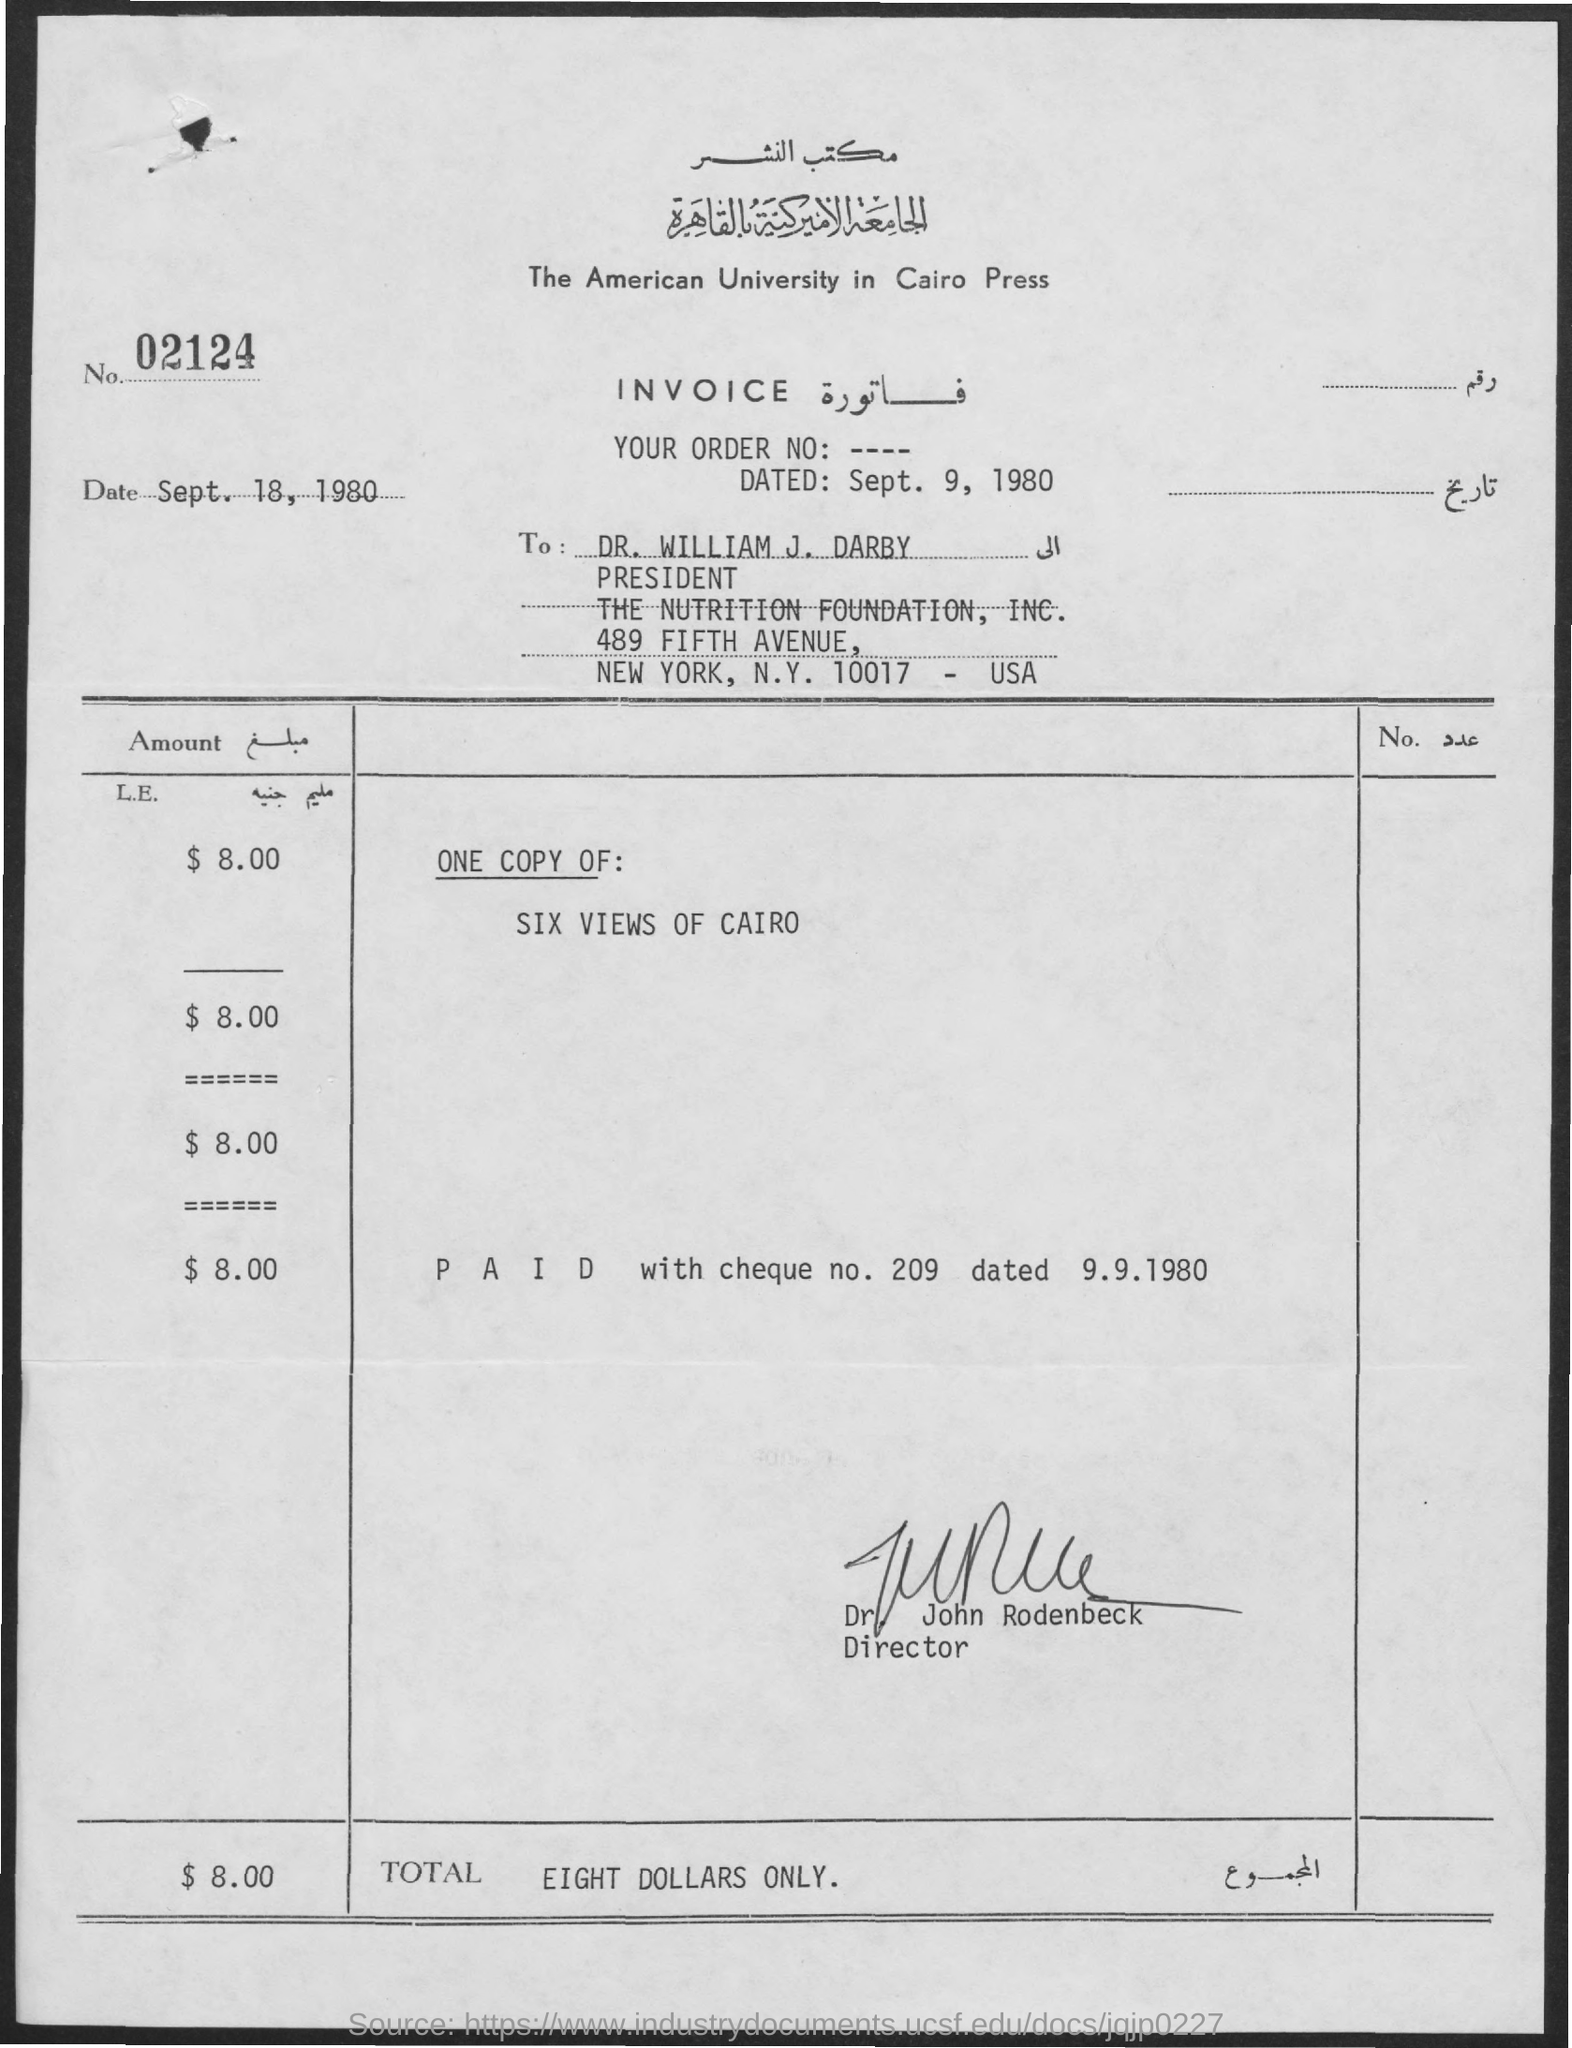What is the cheque number?
Give a very brief answer. 209. What is the order date?
Offer a very short reply. Sept. 9, 1980. What is the name of the director?
Ensure brevity in your answer.  John Rodenbeck. What is the Total?
Ensure brevity in your answer.  Eight dollars only. 